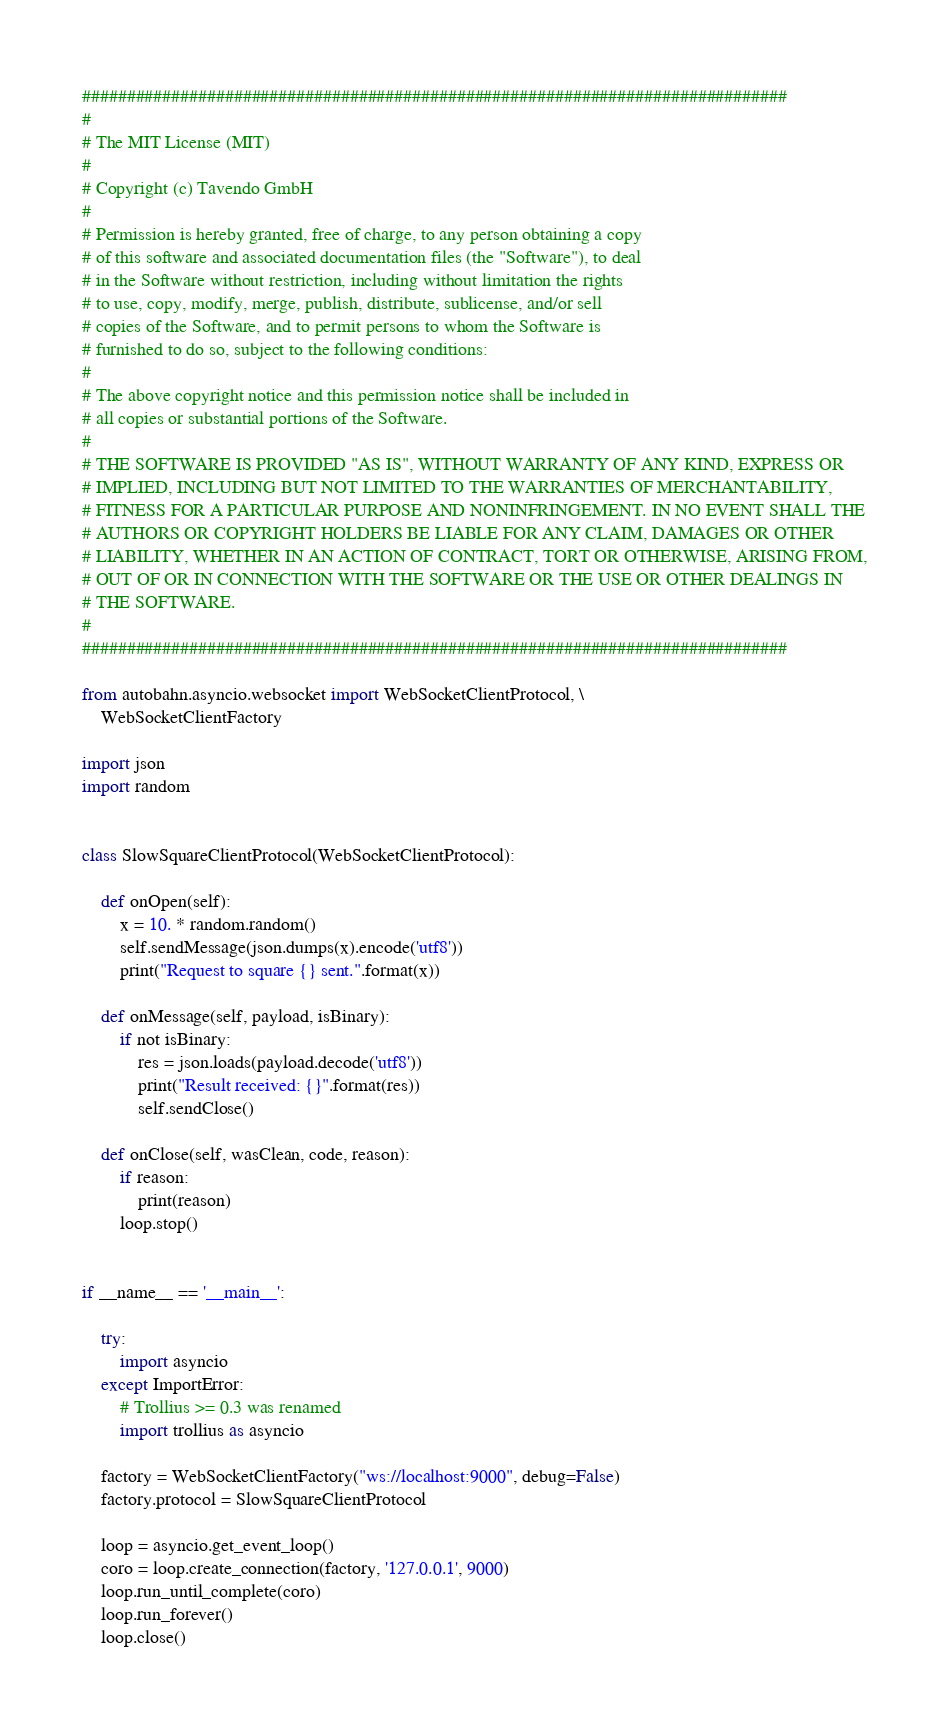Convert code to text. <code><loc_0><loc_0><loc_500><loc_500><_Python_>###############################################################################
#
# The MIT License (MIT)
#
# Copyright (c) Tavendo GmbH
#
# Permission is hereby granted, free of charge, to any person obtaining a copy
# of this software and associated documentation files (the "Software"), to deal
# in the Software without restriction, including without limitation the rights
# to use, copy, modify, merge, publish, distribute, sublicense, and/or sell
# copies of the Software, and to permit persons to whom the Software is
# furnished to do so, subject to the following conditions:
#
# The above copyright notice and this permission notice shall be included in
# all copies or substantial portions of the Software.
#
# THE SOFTWARE IS PROVIDED "AS IS", WITHOUT WARRANTY OF ANY KIND, EXPRESS OR
# IMPLIED, INCLUDING BUT NOT LIMITED TO THE WARRANTIES OF MERCHANTABILITY,
# FITNESS FOR A PARTICULAR PURPOSE AND NONINFRINGEMENT. IN NO EVENT SHALL THE
# AUTHORS OR COPYRIGHT HOLDERS BE LIABLE FOR ANY CLAIM, DAMAGES OR OTHER
# LIABILITY, WHETHER IN AN ACTION OF CONTRACT, TORT OR OTHERWISE, ARISING FROM,
# OUT OF OR IN CONNECTION WITH THE SOFTWARE OR THE USE OR OTHER DEALINGS IN
# THE SOFTWARE.
#
###############################################################################

from autobahn.asyncio.websocket import WebSocketClientProtocol, \
    WebSocketClientFactory

import json
import random


class SlowSquareClientProtocol(WebSocketClientProtocol):

    def onOpen(self):
        x = 10. * random.random()
        self.sendMessage(json.dumps(x).encode('utf8'))
        print("Request to square {} sent.".format(x))

    def onMessage(self, payload, isBinary):
        if not isBinary:
            res = json.loads(payload.decode('utf8'))
            print("Result received: {}".format(res))
            self.sendClose()

    def onClose(self, wasClean, code, reason):
        if reason:
            print(reason)
        loop.stop()


if __name__ == '__main__':

    try:
        import asyncio
    except ImportError:
        # Trollius >= 0.3 was renamed
        import trollius as asyncio

    factory = WebSocketClientFactory("ws://localhost:9000", debug=False)
    factory.protocol = SlowSquareClientProtocol

    loop = asyncio.get_event_loop()
    coro = loop.create_connection(factory, '127.0.0.1', 9000)
    loop.run_until_complete(coro)
    loop.run_forever()
    loop.close()
</code> 